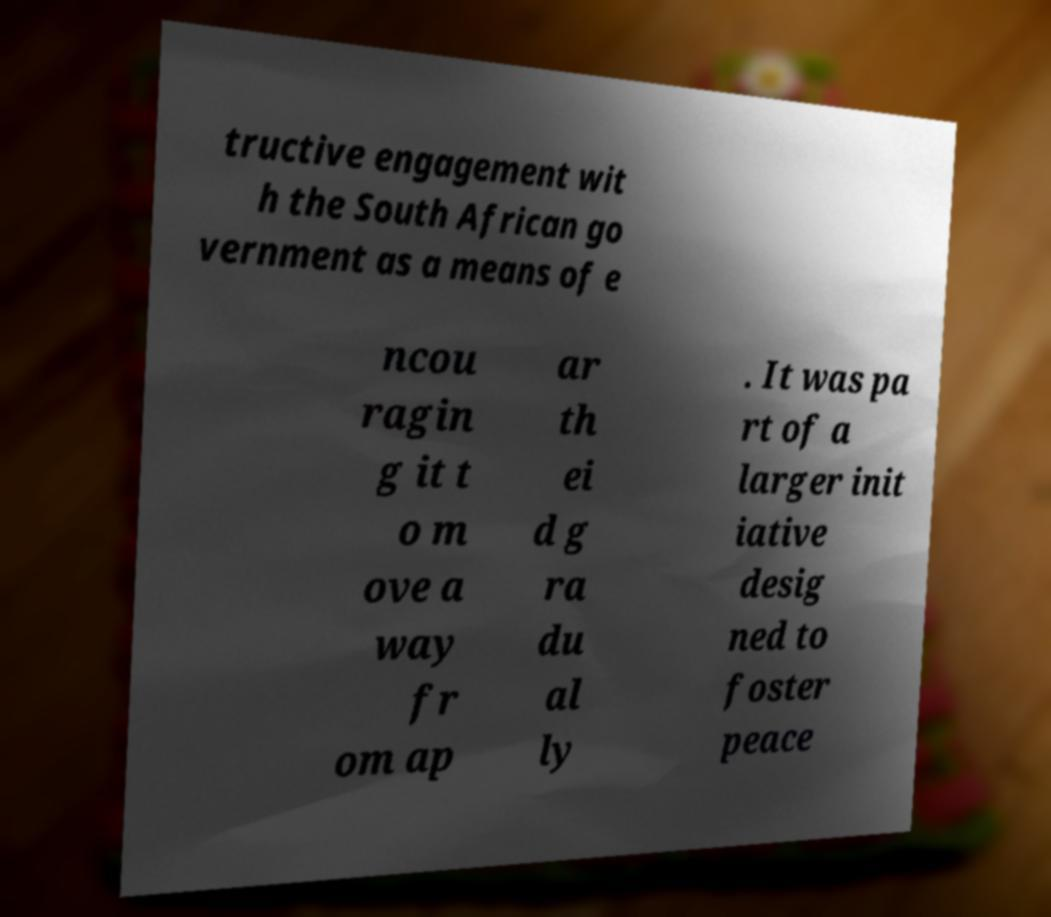Can you read and provide the text displayed in the image?This photo seems to have some interesting text. Can you extract and type it out for me? tructive engagement wit h the South African go vernment as a means of e ncou ragin g it t o m ove a way fr om ap ar th ei d g ra du al ly . It was pa rt of a larger init iative desig ned to foster peace 